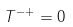Convert formula to latex. <formula><loc_0><loc_0><loc_500><loc_500>T ^ { - + } = 0</formula> 